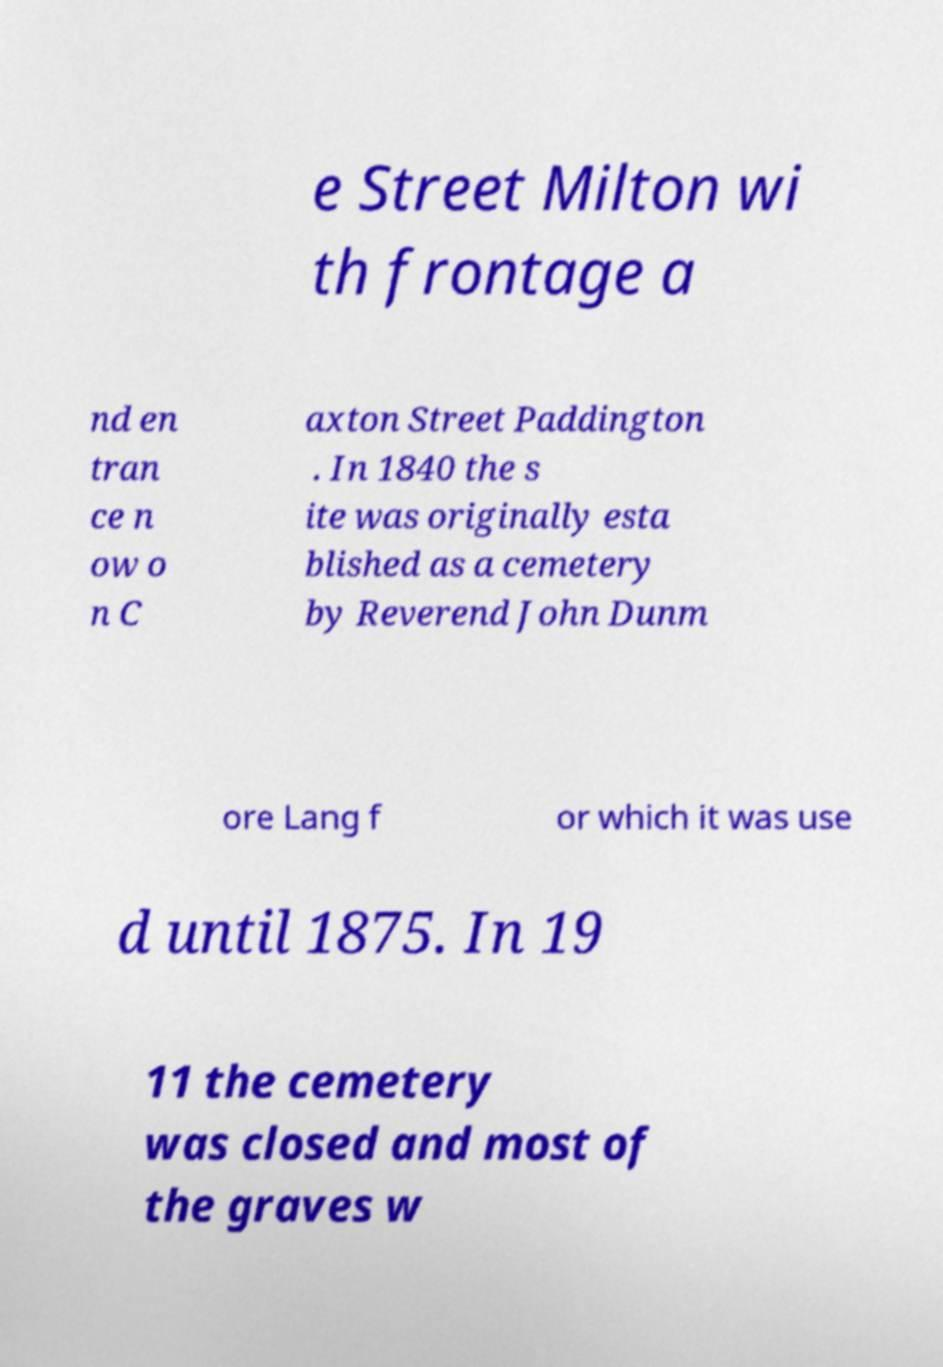There's text embedded in this image that I need extracted. Can you transcribe it verbatim? e Street Milton wi th frontage a nd en tran ce n ow o n C axton Street Paddington . In 1840 the s ite was originally esta blished as a cemetery by Reverend John Dunm ore Lang f or which it was use d until 1875. In 19 11 the cemetery was closed and most of the graves w 